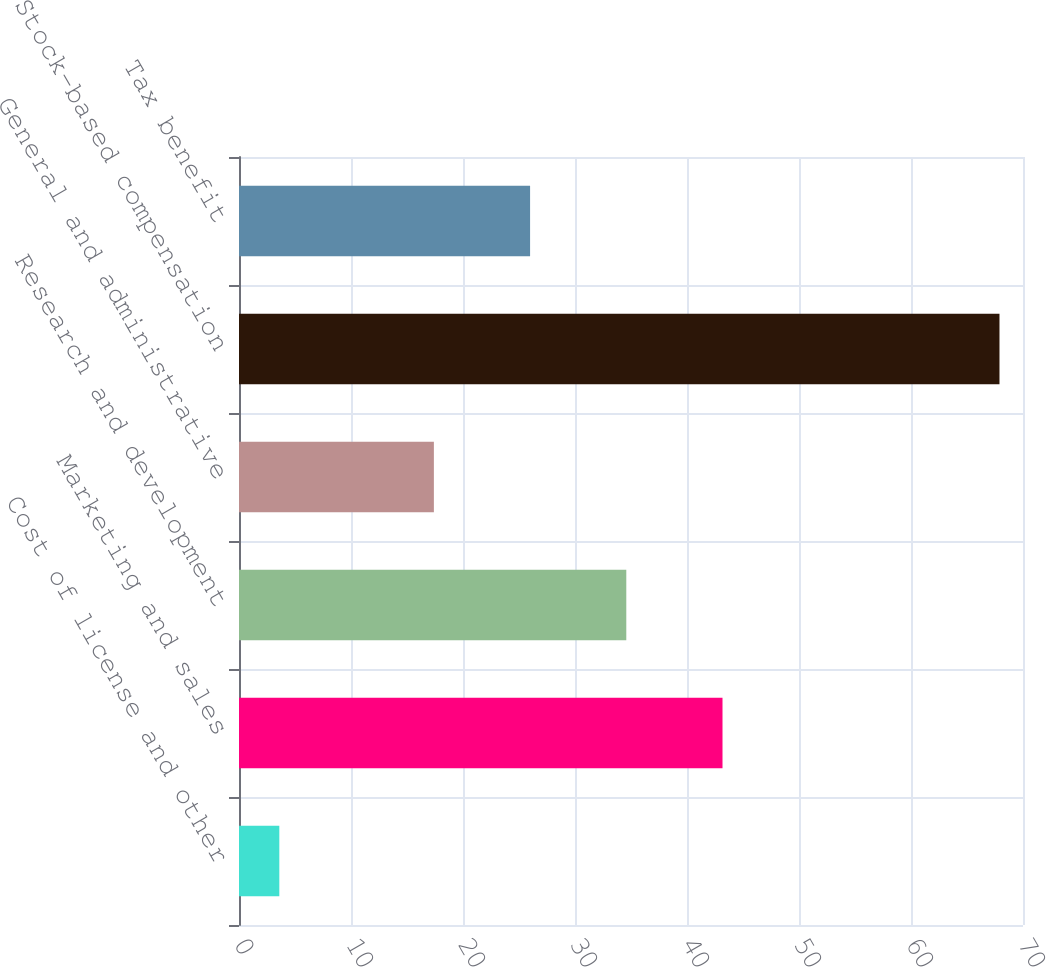Convert chart. <chart><loc_0><loc_0><loc_500><loc_500><bar_chart><fcel>Cost of license and other<fcel>Marketing and sales<fcel>Research and development<fcel>General and administrative<fcel>Stock-based compensation<fcel>Tax benefit<nl><fcel>3.6<fcel>43.17<fcel>34.58<fcel>17.4<fcel>67.9<fcel>25.99<nl></chart> 